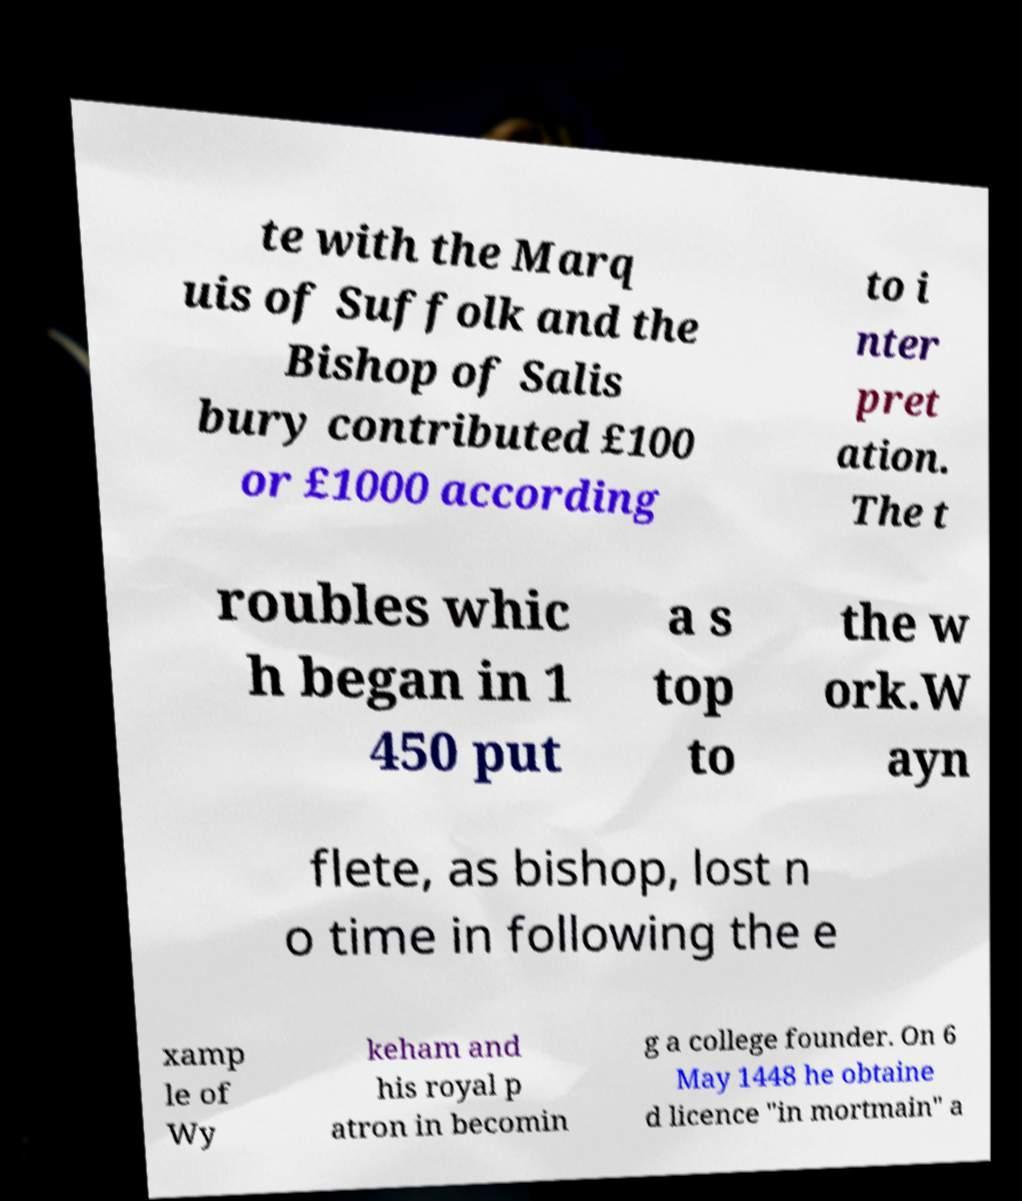I need the written content from this picture converted into text. Can you do that? te with the Marq uis of Suffolk and the Bishop of Salis bury contributed £100 or £1000 according to i nter pret ation. The t roubles whic h began in 1 450 put a s top to the w ork.W ayn flete, as bishop, lost n o time in following the e xamp le of Wy keham and his royal p atron in becomin g a college founder. On 6 May 1448 he obtaine d licence "in mortmain" a 